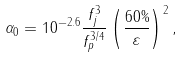<formula> <loc_0><loc_0><loc_500><loc_500>\alpha _ { 0 } = 1 0 ^ { - 2 . 6 } \frac { f _ { j } ^ { 3 } } { f _ { p } ^ { 3 / 4 } } \left ( \frac { 6 0 \% } { \varepsilon } \right ) ^ { 2 } ,</formula> 